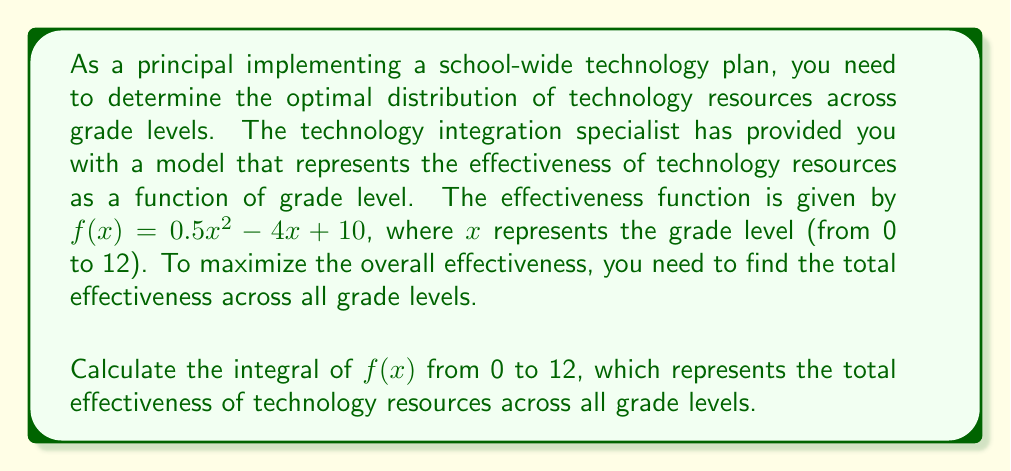Show me your answer to this math problem. To solve this problem, we need to integrate the given function $f(x) = 0.5x^2 - 4x + 10$ from 0 to 12. Let's break it down step-by-step:

1) First, let's find the indefinite integral of $f(x)$:

   $\int f(x) dx = \int (0.5x^2 - 4x + 10) dx$

2) Integrate each term:
   
   $\int 0.5x^2 dx = \frac{1}{6}x^3$
   $\int -4x dx = -2x^2$
   $\int 10 dx = 10x$

3) Combining these, we get the indefinite integral:

   $F(x) = \frac{1}{6}x^3 - 2x^2 + 10x + C$

4) Now, we need to evaluate the definite integral from 0 to 12:

   $\int_0^{12} f(x) dx = F(12) - F(0)$

5) Let's calculate $F(12)$ and $F(0)$:

   $F(12) = \frac{1}{6}(12^3) - 2(12^2) + 10(12) = 288 - 288 + 120 = 120$

   $F(0) = \frac{1}{6}(0^3) - 2(0^2) + 10(0) = 0$

6) Therefore, the definite integral is:

   $\int_0^{12} f(x) dx = F(12) - F(0) = 120 - 0 = 120$

This result represents the total effectiveness of technology resources across all grade levels.
Answer: 120 